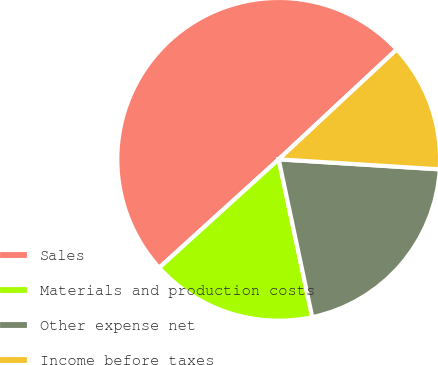<chart> <loc_0><loc_0><loc_500><loc_500><pie_chart><fcel>Sales<fcel>Materials and production costs<fcel>Other expense net<fcel>Income before taxes<nl><fcel>49.79%<fcel>16.61%<fcel>20.67%<fcel>12.92%<nl></chart> 